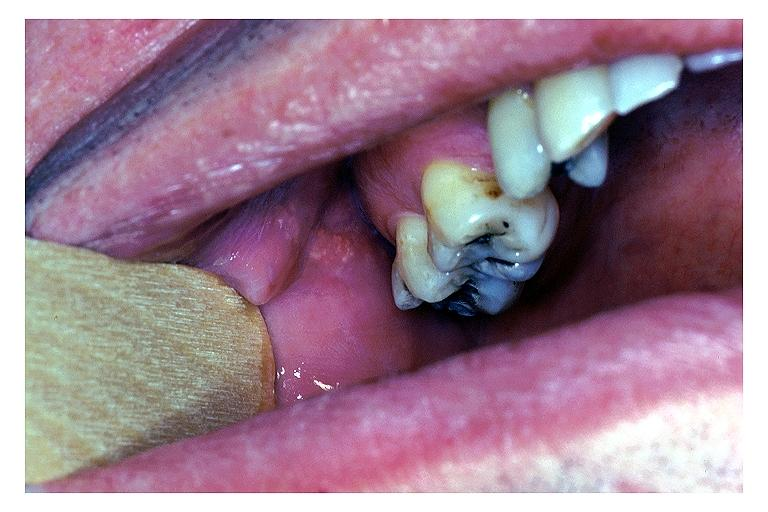what is present?
Answer the question using a single word or phrase. Oral 